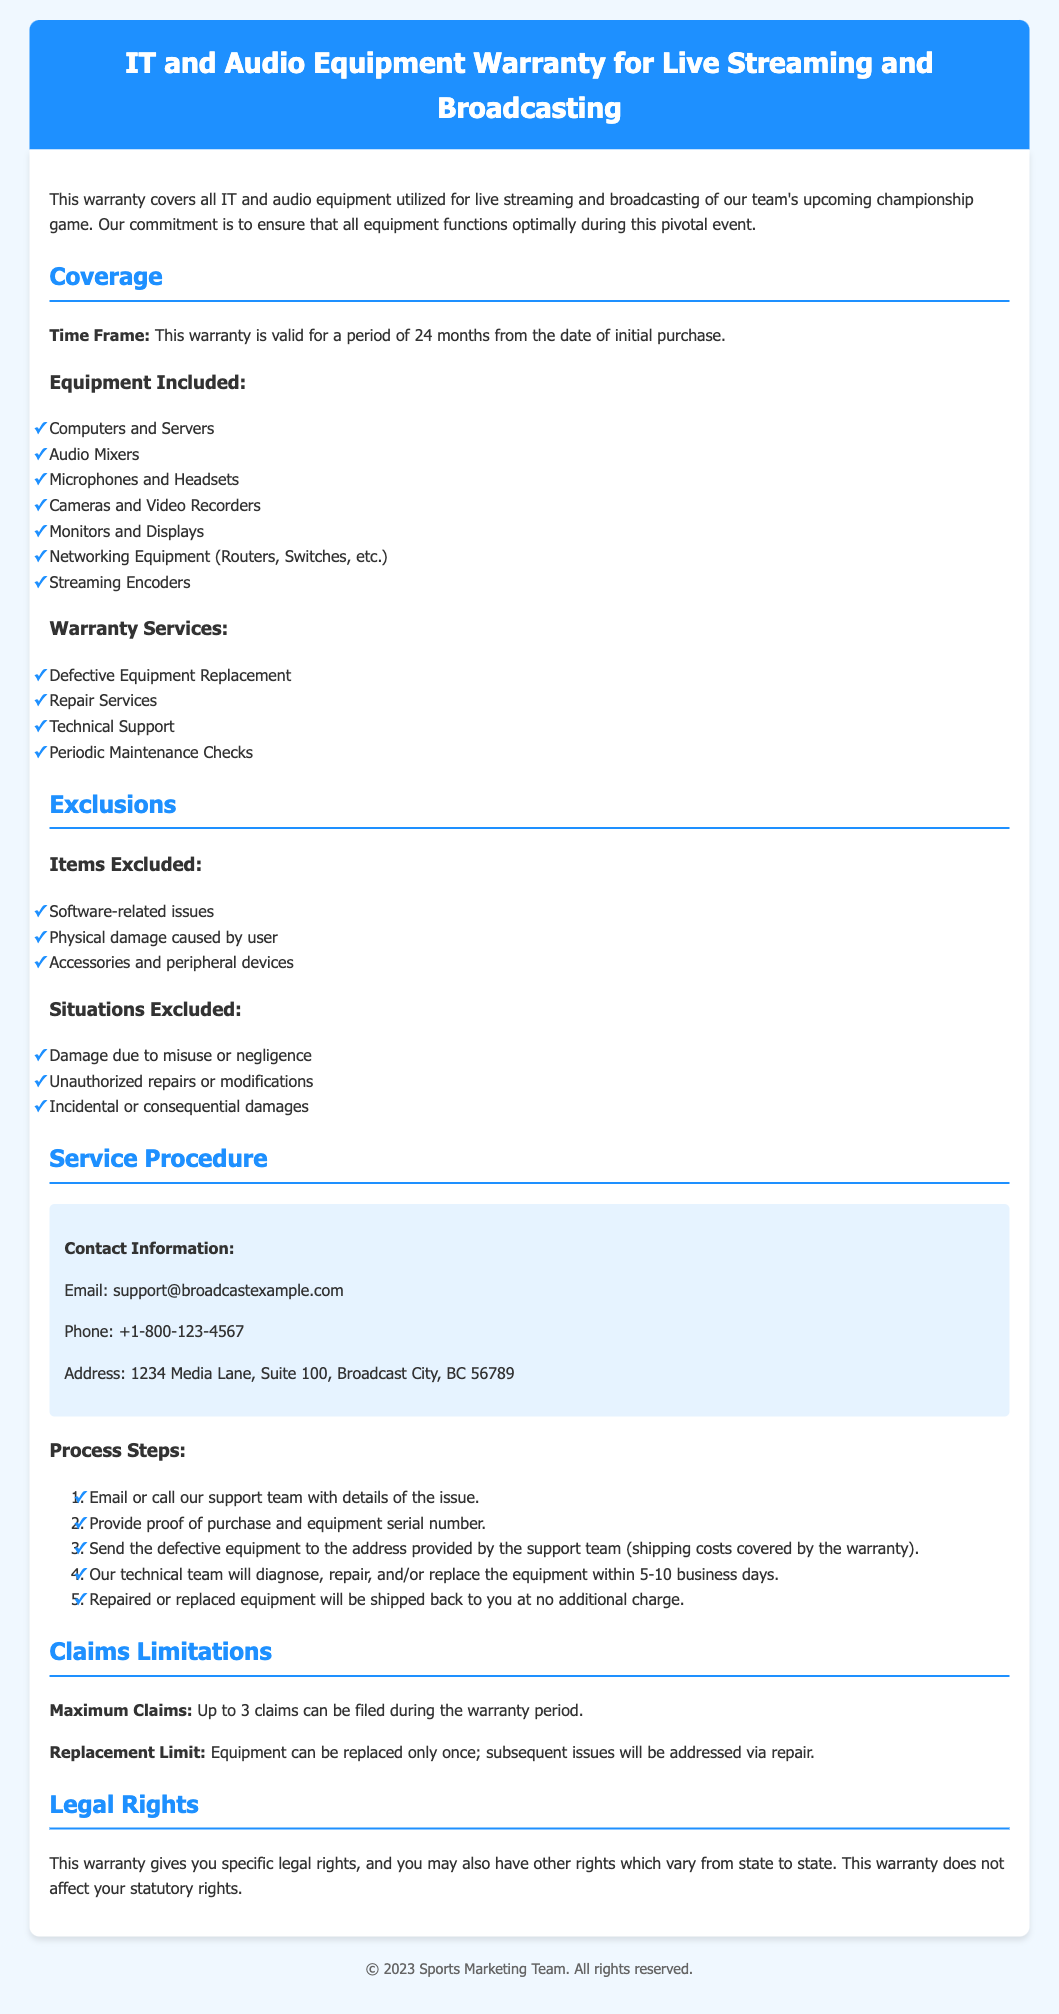what is the time frame of the warranty? The time frame of the warranty is specified as the valid period from the date of initial purchase, which is 24 months.
Answer: 24 months which equipment is excluded from the warranty? The document lists specific items that are excluded, such as software-related issues, physical damage caused by the user, and accessories.
Answer: Software-related issues how many claims can be filed during the warranty period? The document indicates a limit on claims that can be filed during the warranty period, stating that a maximum of 3 claims can be made.
Answer: 3 claims what service is provided under the warranty? The warranty covers several services, including defective equipment replacement, which is mentioned in the document.
Answer: Defective Equipment Replacement what is the contact email for warranty support? The document provides contact information, including an email address that users can reach for support regarding the warranty.
Answer: support@broadcastexample.com how long does it take to have equipment repaired or replaced? The document describes the timeline for diagnosing and handling equipment issues, stating the turnaround time is between 5 to 10 business days.
Answer: 5-10 business days what happens if equipment needs to be replaced more than once? The warranty specifies that equipment can only be replaced once; any subsequent issues will lead to repairs instead.
Answer: Repaired which items are mentioned as included in the warranty? A list in the document details the equipment included under the warranty, providing examples such as computers and audio mixers.
Answer: Computers and Servers what is the maximum number of claims allowed? The document addresses the claim limitations and highlights that there is a maximum number of claims permitted during the warranty period.
Answer: 3 claims 